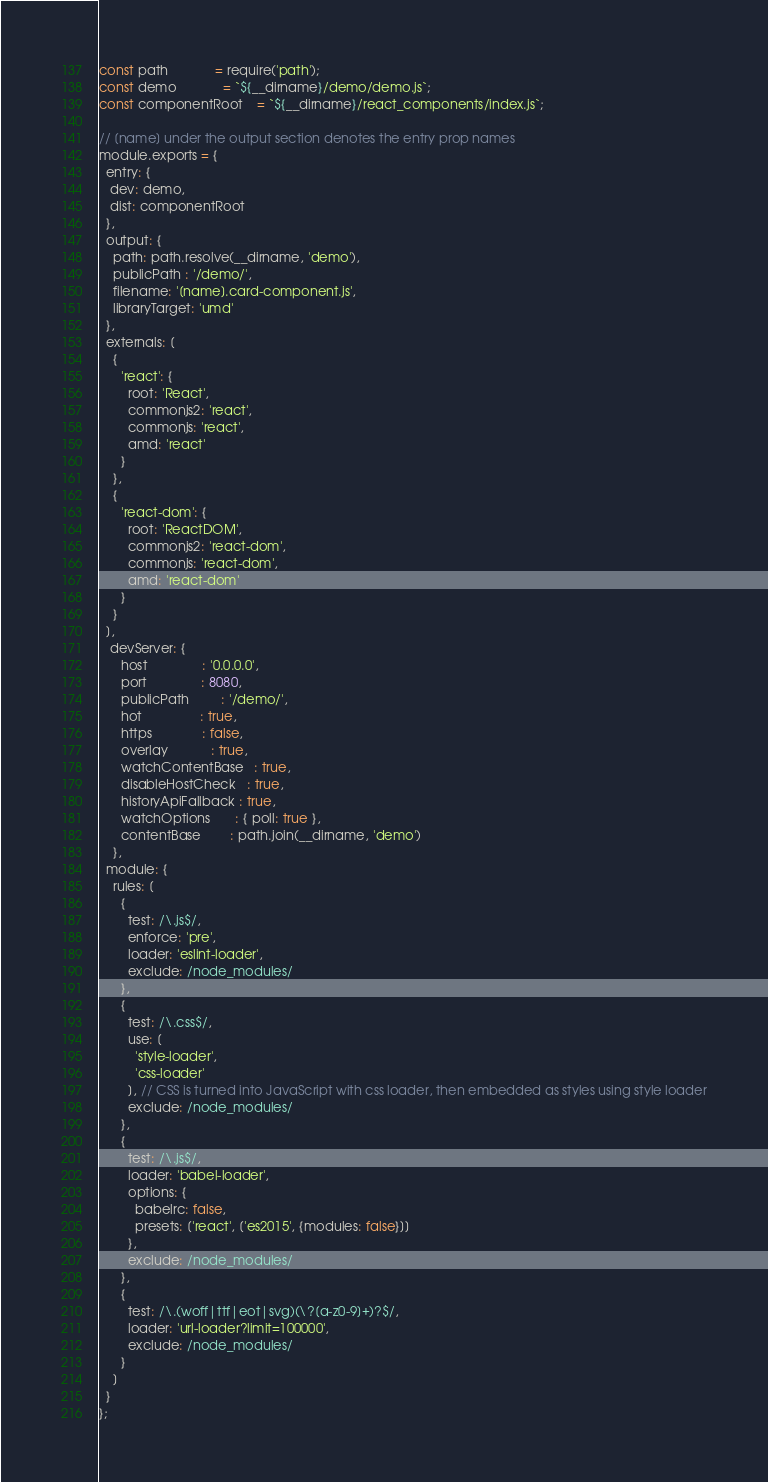Convert code to text. <code><loc_0><loc_0><loc_500><loc_500><_JavaScript_>const path             = require('path');
const demo             = `${__dirname}/demo/demo.js`;
const componentRoot    = `${__dirname}/react_components/index.js`;

// [name] under the output section denotes the entry prop names
module.exports = {
  entry: {
   dev: demo,
   dist: componentRoot
  },
  output: {
    path: path.resolve(__dirname, 'demo'),
    publicPath : '/demo/',
    filename: '[name].card-component.js',
    libraryTarget: 'umd'
  },
  externals: [
    {
      'react': {
        root: 'React',
        commonjs2: 'react',
        commonjs: 'react',
        amd: 'react'
      }
    },
    {
      'react-dom': {
        root: 'ReactDOM',
        commonjs2: 'react-dom',
        commonjs: 'react-dom',
        amd: 'react-dom'
      }
    }
  ],
   devServer: {
      host               : '0.0.0.0',
      port               : 8080,
      publicPath         : '/demo/',
      hot                : true,
      https              : false,
      overlay            : true,
      watchContentBase   : true,
      disableHostCheck   : true,
      historyApiFallback : true,
      watchOptions       : { poll: true },
      contentBase        : path.join(__dirname, 'demo')
    },
  module: {
    rules: [
      {
        test: /\.js$/,
        enforce: 'pre',
        loader: 'eslint-loader',
        exclude: /node_modules/
      },
      {
        test: /\.css$/,
        use: [
          'style-loader',
          'css-loader'
        ], // CSS is turned into JavaScript with css loader, then embedded as styles using style loader
        exclude: /node_modules/
      },
      {
        test: /\.js$/,
        loader: 'babel-loader',
        options: {
          babelrc: false,
          presets: ['react', ['es2015', {modules: false}]]
        },
        exclude: /node_modules/
      },
      {
        test: /\.(woff|ttf|eot|svg)(\?[a-z0-9]+)?$/,
        loader: 'url-loader?limit=100000',
        exclude: /node_modules/
      }
    ]
  }
};
</code> 